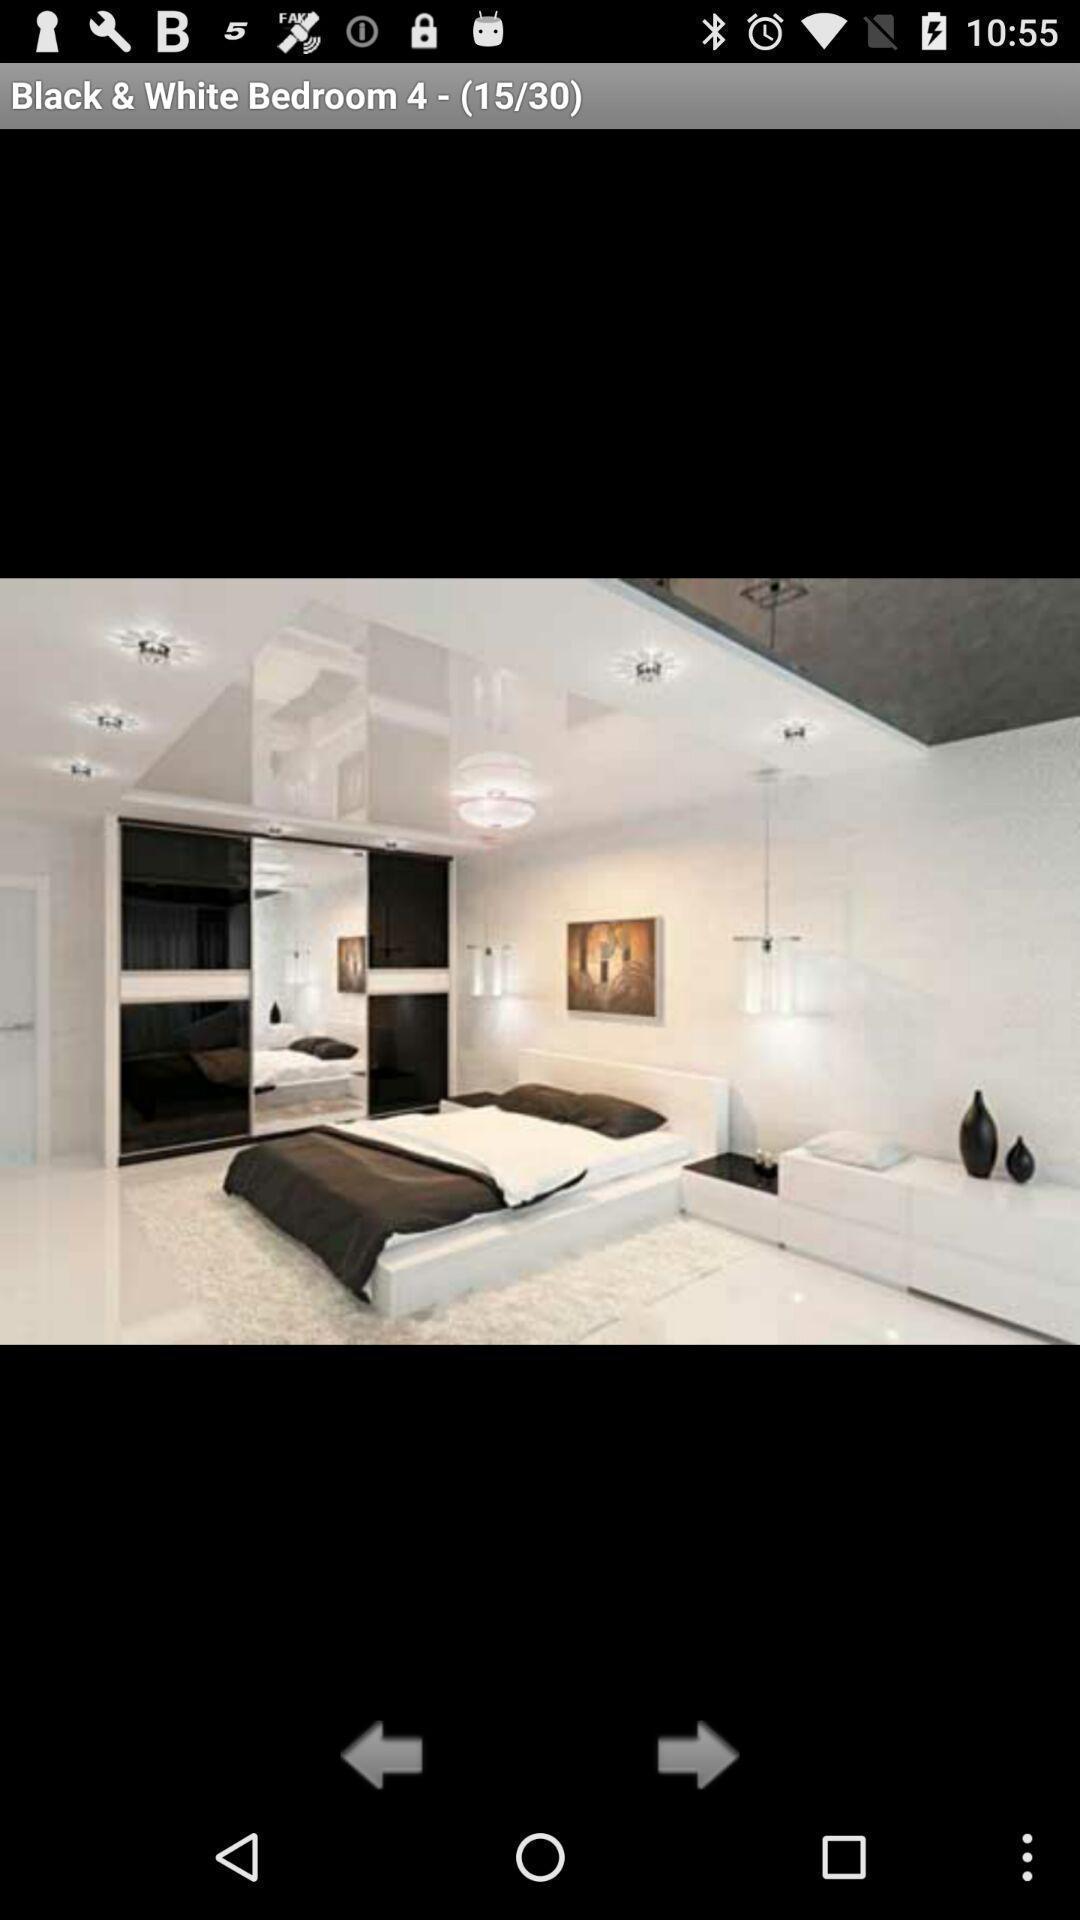Provide a textual representation of this image. Page shows a picture from gallery. 